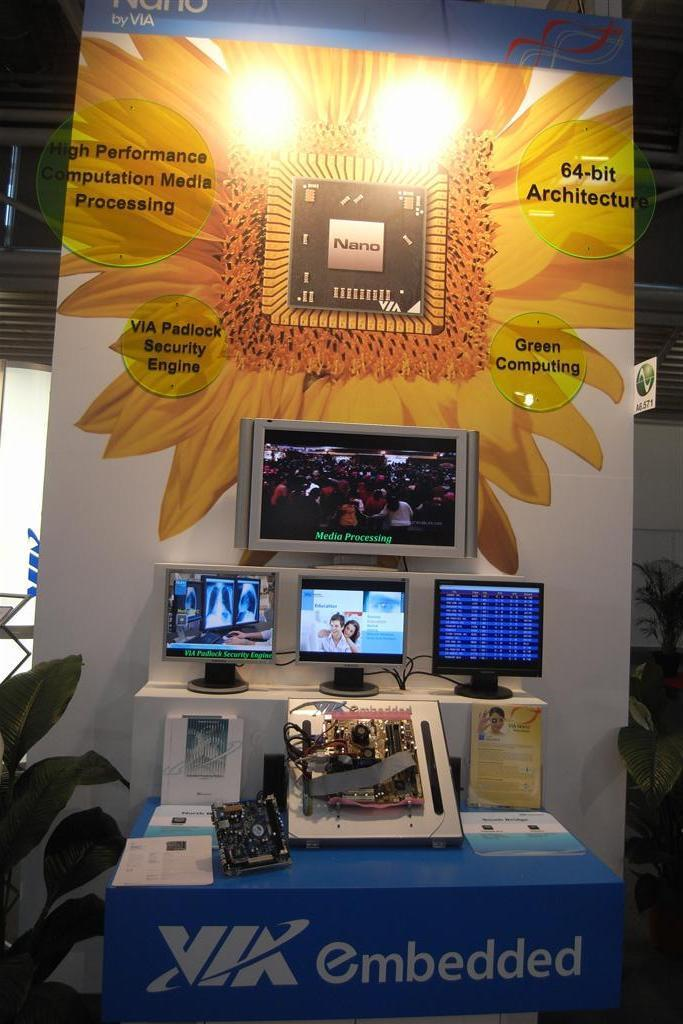Provide a one-sentence caption for the provided image. a display of NANO sponsored by VIA Embedded. 